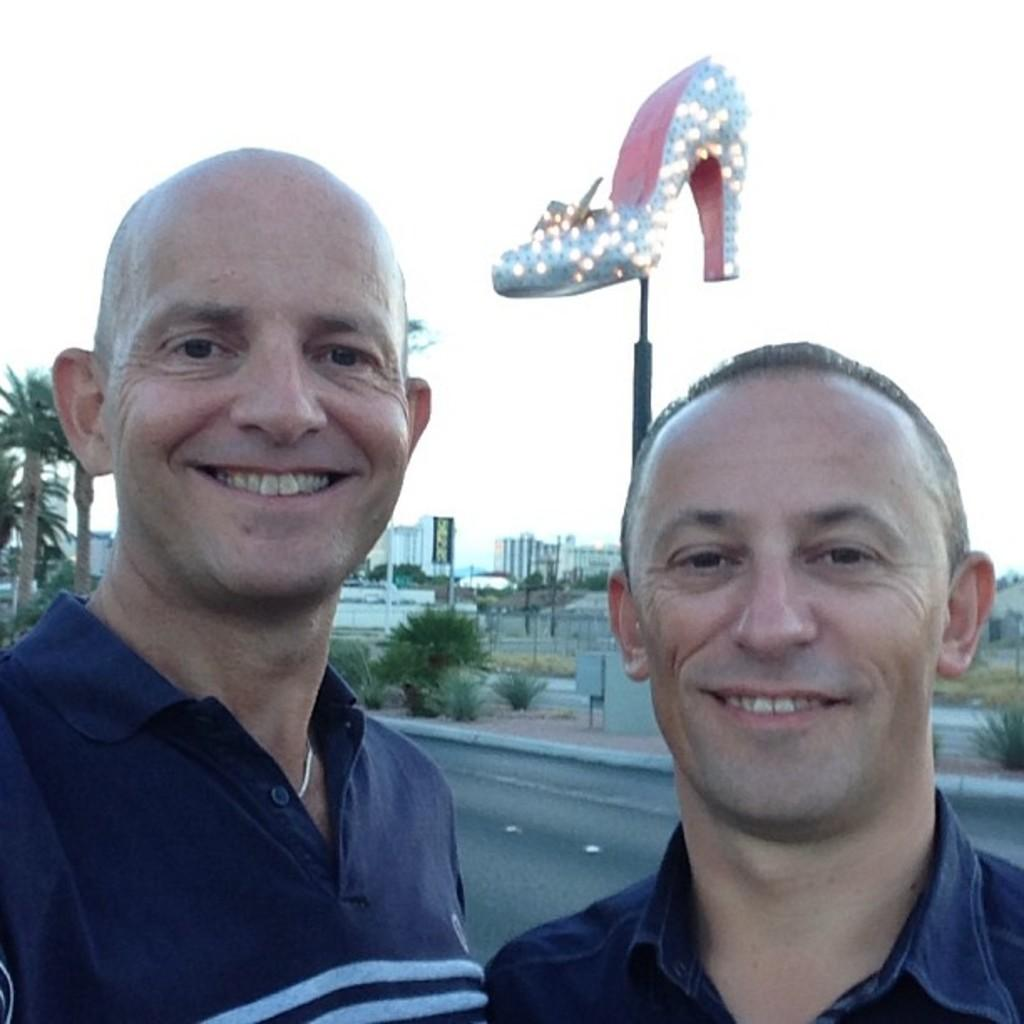How many people are in the foreground of the image? There are two men in the foreground of the image. What can be seen in the background of the image? There are trees, a sculpture of footwear, and buildings in the background of the image. Can you see a jellyfish swimming in the image? There is no jellyfish present in the image. What type of parent is depicted in the image? There is no parent depicted in the image. 